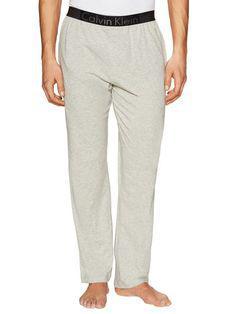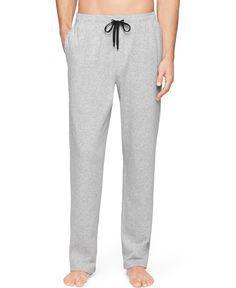The first image is the image on the left, the second image is the image on the right. Considering the images on both sides, is "There are two pairs of grey athletic pants." valid? Answer yes or no. Yes. 